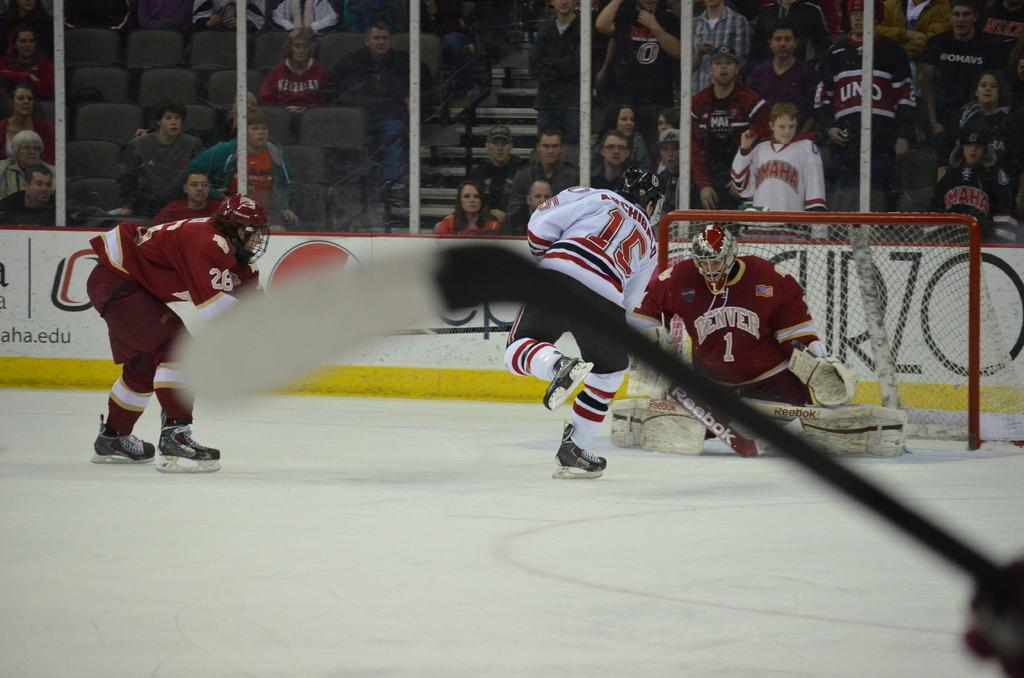Provide a one-sentence caption for the provided image. A hockey game is in progress and Denver is defending the goal. 